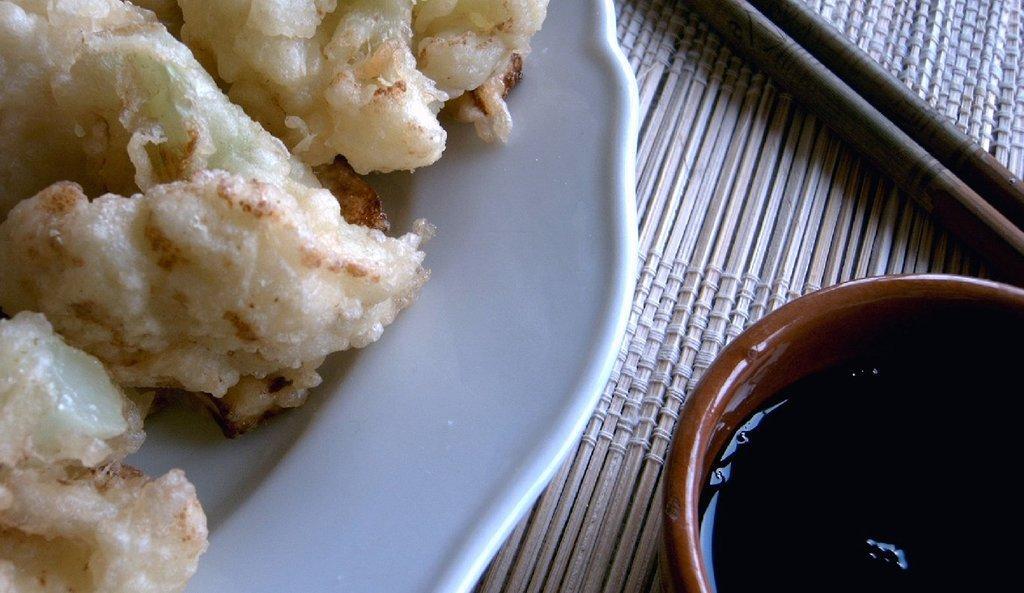Please provide a concise description of this image. Food is highlighted in this picture. Food is presented in a plate. Beside this place there is a bowl with liquid. These are chopsticks. 